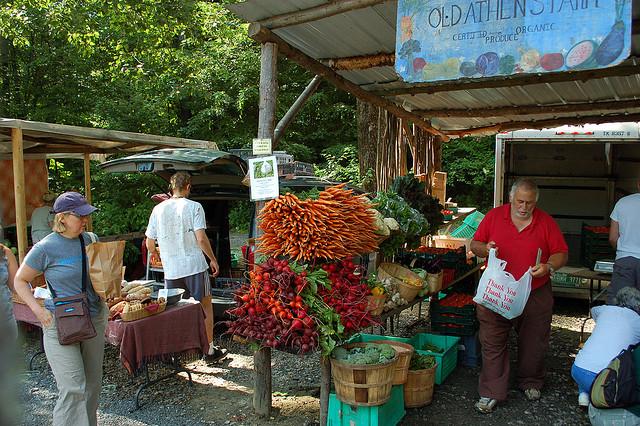What  is the old man carrying?
Concise answer only. Bag. What color is the older man's shirt?
Be succinct. Red. What kind of bag is the lady carrying in her arms?
Short answer required. Paper. 